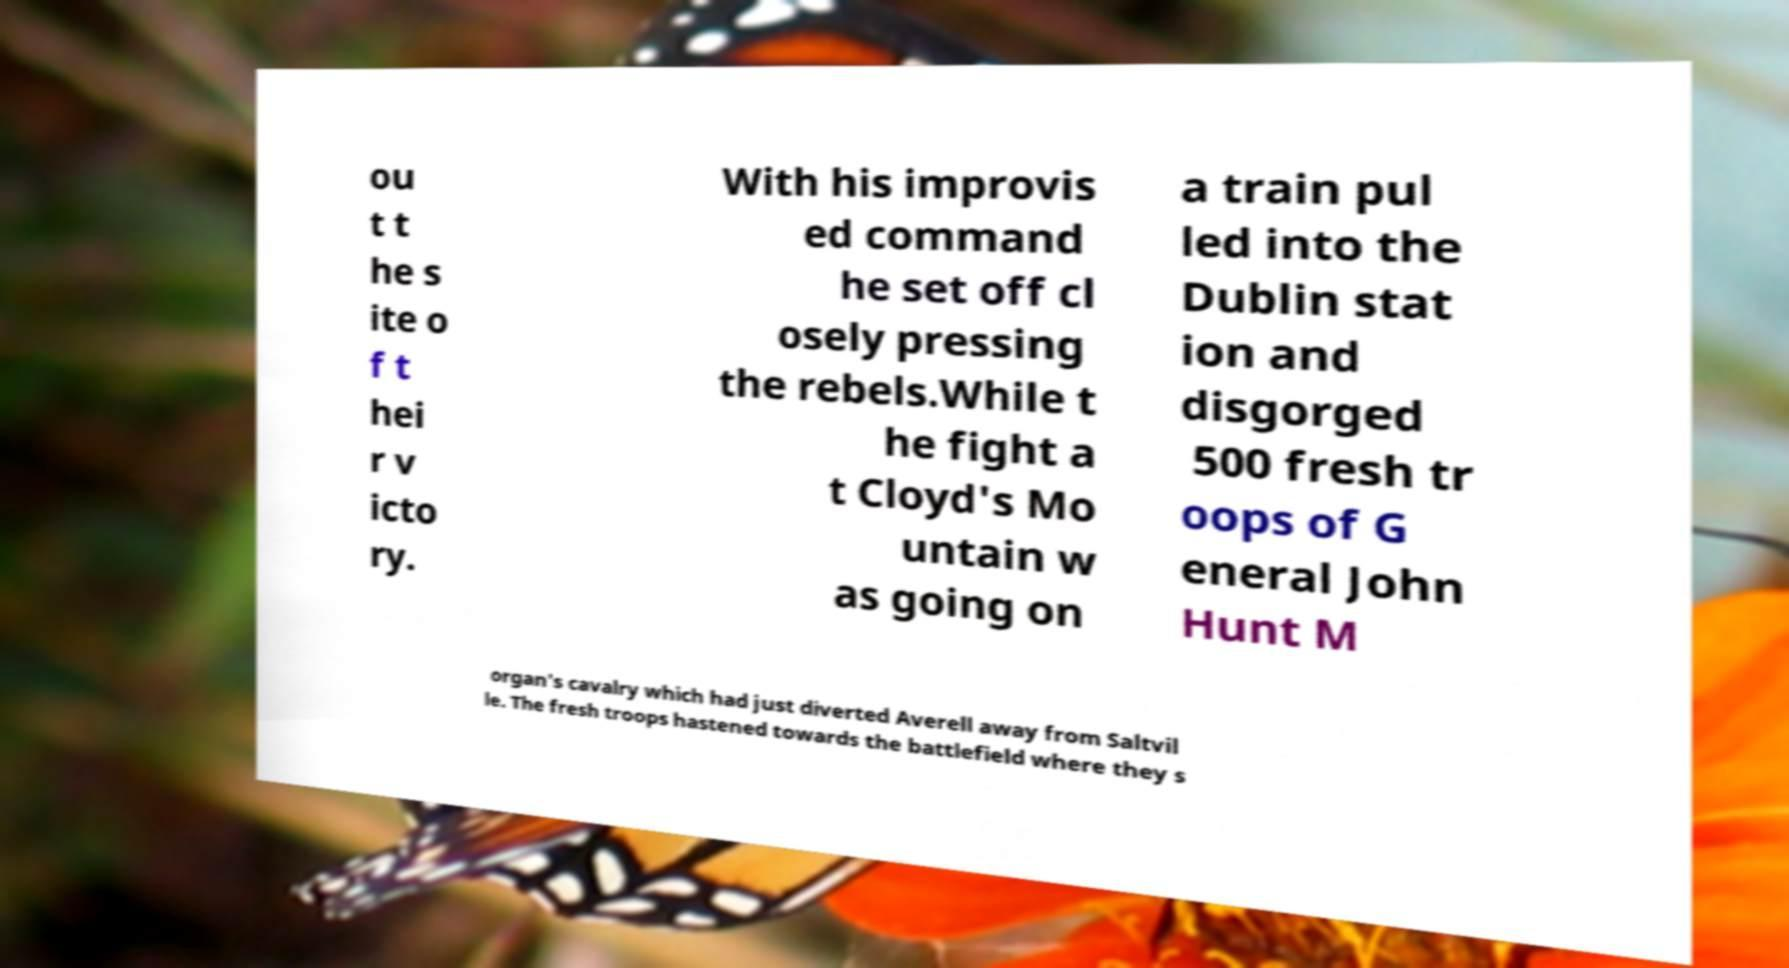Can you read and provide the text displayed in the image?This photo seems to have some interesting text. Can you extract and type it out for me? ou t t he s ite o f t hei r v icto ry. With his improvis ed command he set off cl osely pressing the rebels.While t he fight a t Cloyd's Mo untain w as going on a train pul led into the Dublin stat ion and disgorged 500 fresh tr oops of G eneral John Hunt M organ's cavalry which had just diverted Averell away from Saltvil le. The fresh troops hastened towards the battlefield where they s 